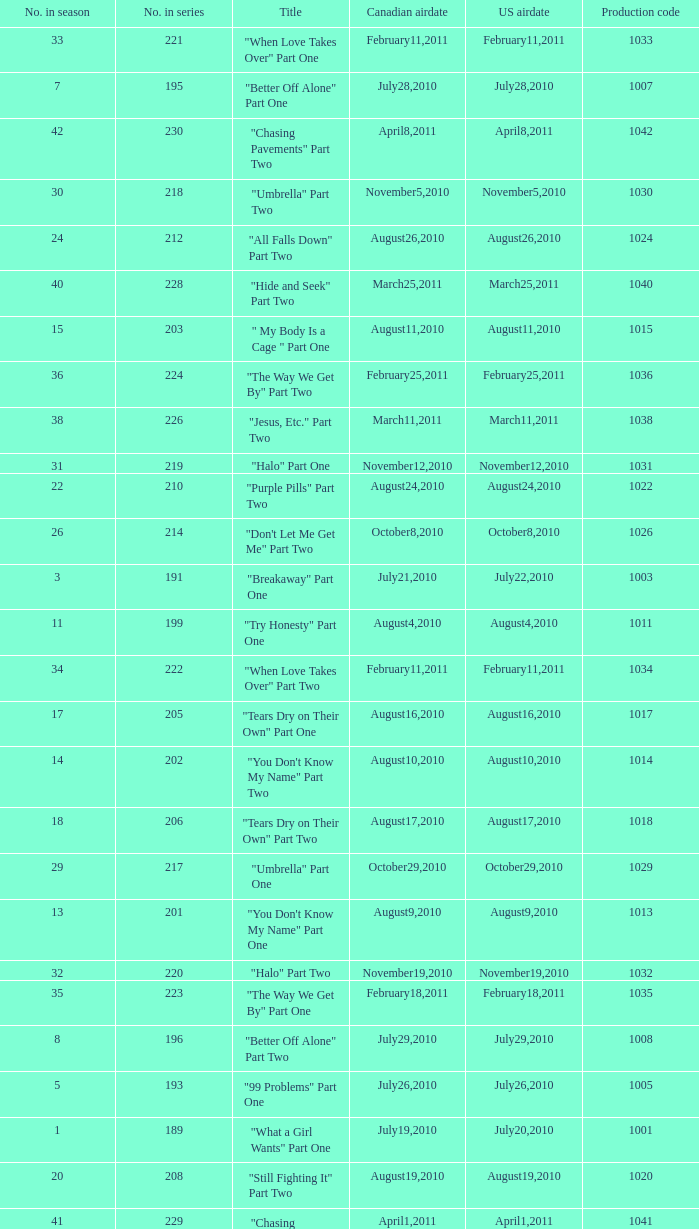Could you help me parse every detail presented in this table? {'header': ['No. in season', 'No. in series', 'Title', 'Canadian airdate', 'US airdate', 'Production code'], 'rows': [['33', '221', '"When Love Takes Over" Part One', 'February11,2011', 'February11,2011', '1033'], ['7', '195', '"Better Off Alone" Part One', 'July28,2010', 'July28,2010', '1007'], ['42', '230', '"Chasing Pavements" Part Two', 'April8,2011', 'April8,2011', '1042'], ['30', '218', '"Umbrella" Part Two', 'November5,2010', 'November5,2010', '1030'], ['24', '212', '"All Falls Down" Part Two', 'August26,2010', 'August26,2010', '1024'], ['40', '228', '"Hide and Seek" Part Two', 'March25,2011', 'March25,2011', '1040'], ['15', '203', '" My Body Is a Cage " Part One', 'August11,2010', 'August11,2010', '1015'], ['36', '224', '"The Way We Get By" Part Two', 'February25,2011', 'February25,2011', '1036'], ['38', '226', '"Jesus, Etc." Part Two', 'March11,2011', 'March11,2011', '1038'], ['31', '219', '"Halo" Part One', 'November12,2010', 'November12,2010', '1031'], ['22', '210', '"Purple Pills" Part Two', 'August24,2010', 'August24,2010', '1022'], ['26', '214', '"Don\'t Let Me Get Me" Part Two', 'October8,2010', 'October8,2010', '1026'], ['3', '191', '"Breakaway" Part One', 'July21,2010', 'July22,2010', '1003'], ['11', '199', '"Try Honesty" Part One', 'August4,2010', 'August4,2010', '1011'], ['34', '222', '"When Love Takes Over" Part Two', 'February11,2011', 'February11,2011', '1034'], ['17', '205', '"Tears Dry on Their Own" Part One', 'August16,2010', 'August16,2010', '1017'], ['14', '202', '"You Don\'t Know My Name" Part Two', 'August10,2010', 'August10,2010', '1014'], ['18', '206', '"Tears Dry on Their Own" Part Two', 'August17,2010', 'August17,2010', '1018'], ['29', '217', '"Umbrella" Part One', 'October29,2010', 'October29,2010', '1029'], ['13', '201', '"You Don\'t Know My Name" Part One', 'August9,2010', 'August9,2010', '1013'], ['32', '220', '"Halo" Part Two', 'November19,2010', 'November19,2010', '1032'], ['35', '223', '"The Way We Get By" Part One', 'February18,2011', 'February18,2011', '1035'], ['8', '196', '"Better Off Alone" Part Two', 'July29,2010', 'July29,2010', '1008'], ['5', '193', '"99 Problems" Part One', 'July26,2010', 'July26,2010', '1005'], ['1', '189', '"What a Girl Wants" Part One', 'July19,2010', 'July20,2010', '1001'], ['20', '208', '"Still Fighting It" Part Two', 'August19,2010', 'August19,2010', '1020'], ['41', '229', '"Chasing Pavements" Part One', 'April1,2011', 'April1,2011', '1041'], ['2', '190', '"What a Girl Wants" Part Two', 'July20,2010', 'July21,2010', '1002'], ['16', '204', '" My Body Is a Cage " Part Two', 'August12,2010', 'August12,2010', '1016'], ['27', '215', '"Love Lockdown" Part One', 'October15,2010', 'October15,2010', '1027'], ['43', '231', '"Drop the World" Part One', 'April15,2011', 'April15,2011', '1043'], ['12', '200', '"Try Honesty" Part Two', 'August5,2010', 'August5,2010', '1012'], ['21', '209', '"Purple Pills" Part One', 'August23,2010', 'August23,2010', '1021'], ['28', '216', '"Love Lockdown" Part Two', 'October22,2010', 'October22,2010', '1028'], ['6', '194', '"99 Problems" Part Two', 'July27,2010', 'July27,2010', '1006'], ['39', '227', '"Hide and Seek" Part One', 'March18,2011', 'March18,2011', '1039'], ['4', '192', '"Breakaway" Part Two', 'July22,2010', 'July23,2010', '1004'], ['37', '225', '"Jesus, Etc." Part One', 'March4,2011', 'March4,2011', '1037'], ['25', '213', '"Don\'t Let Me Get Me" Part One', 'October8,2010', 'October8,2010', '1025'], ['23', '211', '"All Falls Down" Part One', 'August25,2010', 'August25,2010', '1023'], ['19', '207', '"Still Fighting It" Part One', 'August18,2010', 'August18,2010', '1019']]} What was the us airdate of "love lockdown" part one? October15,2010. 